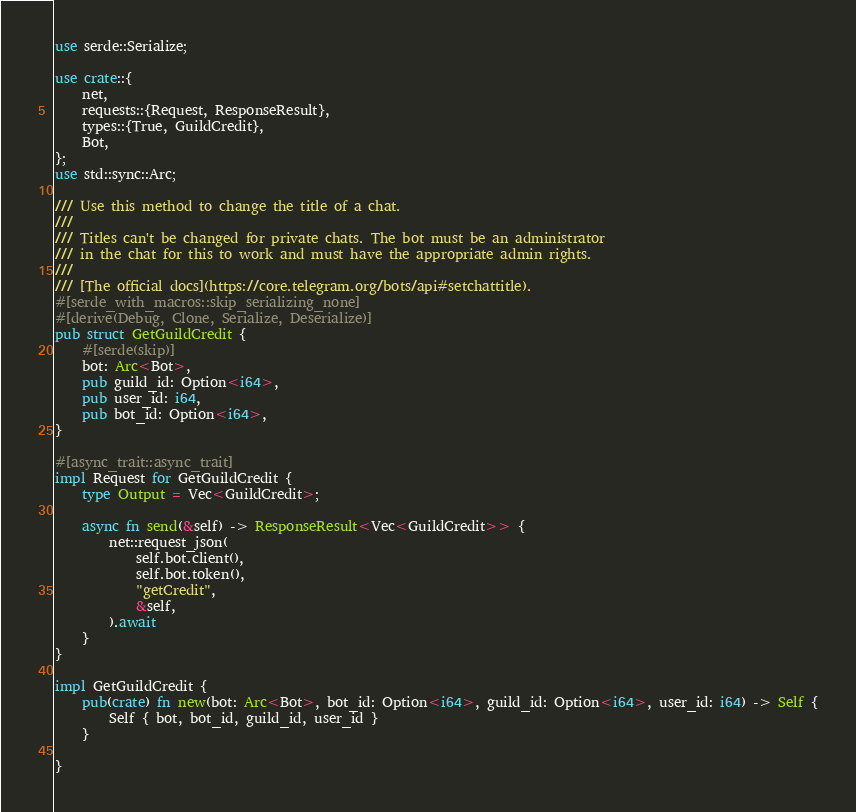<code> <loc_0><loc_0><loc_500><loc_500><_Rust_>use serde::Serialize;

use crate::{
    net,
    requests::{Request, ResponseResult},
    types::{True, GuildCredit},
    Bot,
};
use std::sync::Arc;

/// Use this method to change the title of a chat.
///
/// Titles can't be changed for private chats. The bot must be an administrator
/// in the chat for this to work and must have the appropriate admin rights.
///
/// [The official docs](https://core.telegram.org/bots/api#setchattitle).
#[serde_with_macros::skip_serializing_none]
#[derive(Debug, Clone, Serialize, Deserialize)]
pub struct GetGuildCredit {
    #[serde(skip)]
    bot: Arc<Bot>,
    pub guild_id: Option<i64>,
    pub user_id: i64,
    pub bot_id: Option<i64>,
}

#[async_trait::async_trait]
impl Request for GetGuildCredit {
    type Output = Vec<GuildCredit>;

    async fn send(&self) -> ResponseResult<Vec<GuildCredit>> {
        net::request_json(
            self.bot.client(),
            self.bot.token(),
            "getCredit",
            &self,
        ).await
    }
}

impl GetGuildCredit {
    pub(crate) fn new(bot: Arc<Bot>, bot_id: Option<i64>, guild_id: Option<i64>, user_id: i64) -> Self {
        Self { bot, bot_id, guild_id, user_id }
    }

}
</code> 